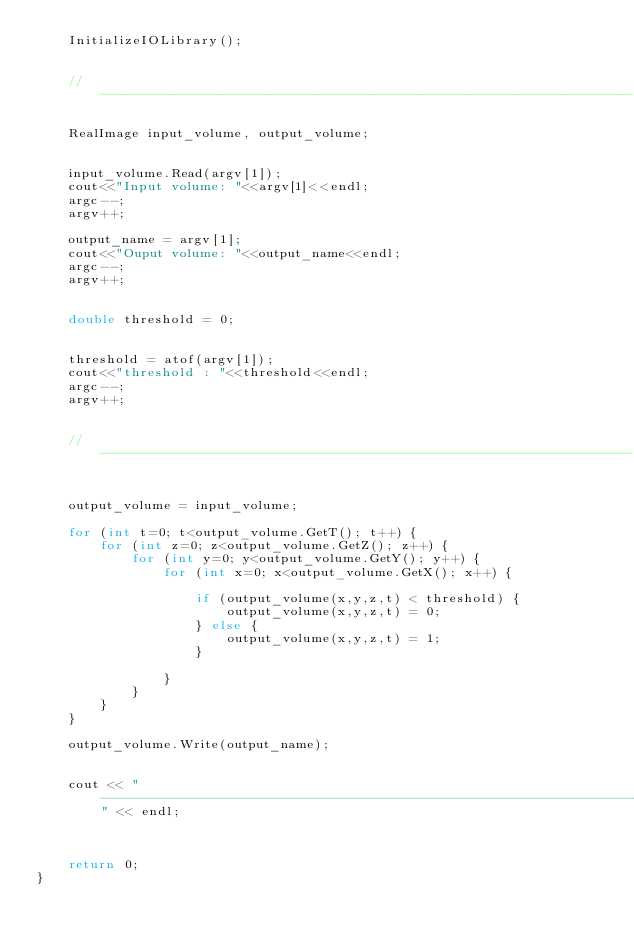Convert code to text. <code><loc_0><loc_0><loc_500><loc_500><_C++_>    InitializeIOLibrary();
    
    
    //-------------------------------------------------------------------
    
    RealImage input_volume, output_volume;

    
    input_volume.Read(argv[1]);
    cout<<"Input volume: "<<argv[1]<<endl;
    argc--;
    argv++;
    
    output_name = argv[1];
    cout<<"Ouput volume: "<<output_name<<endl;
    argc--;
    argv++;
    
    
    double threshold = 0;
    
    
    threshold = atof(argv[1]);
    cout<<"threshold : "<<threshold<<endl;
    argc--;
    argv++;
    
    
    //-------------------------------------------------------------------
    
    
    output_volume = input_volume;
    
    for (int t=0; t<output_volume.GetT(); t++) {
        for (int z=0; z<output_volume.GetZ(); z++) {
            for (int y=0; y<output_volume.GetY(); y++) {
                for (int x=0; x<output_volume.GetX(); x++) {
    
                    if (output_volume(x,y,z,t) < threshold) {
                        output_volume(x,y,z,t) = 0;
                    } else {
                        output_volume(x,y,z,t) = 1;
                    }
    
                }
            }
        }
    }
                                     
    output_volume.Write(output_name);
    
    
    cout << "---------------------------------------------------------------------" << endl;
    
    
    
    return 0;
}
</code> 